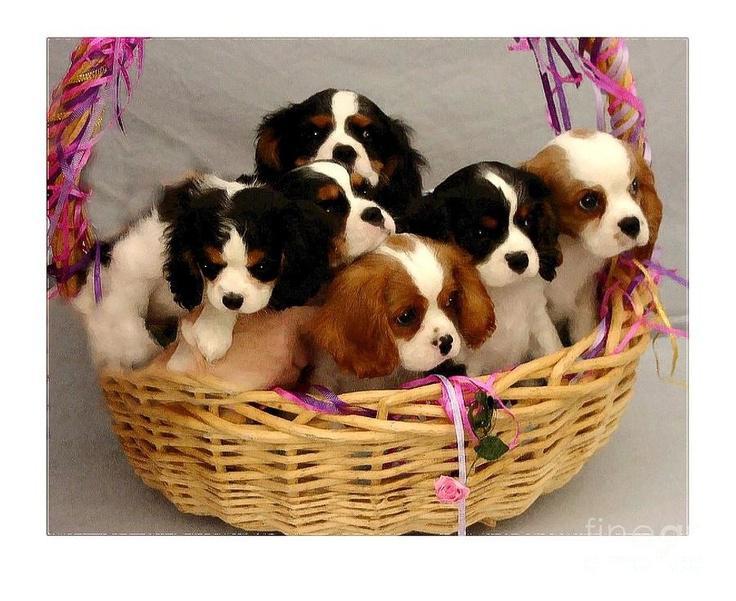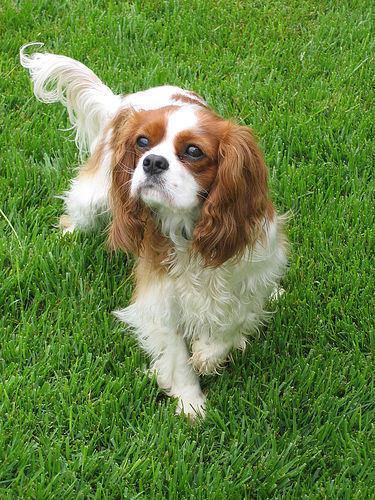The first image is the image on the left, the second image is the image on the right. Evaluate the accuracy of this statement regarding the images: "The left image contains at least three dogs.". Is it true? Answer yes or no. Yes. The first image is the image on the left, the second image is the image on the right. For the images displayed, is the sentence "In the left image, there is no less than two dogs in a woven basket, and in the right image there is a single brown and white dog" factually correct? Answer yes or no. Yes. 